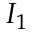<formula> <loc_0><loc_0><loc_500><loc_500>I _ { 1 }</formula> 